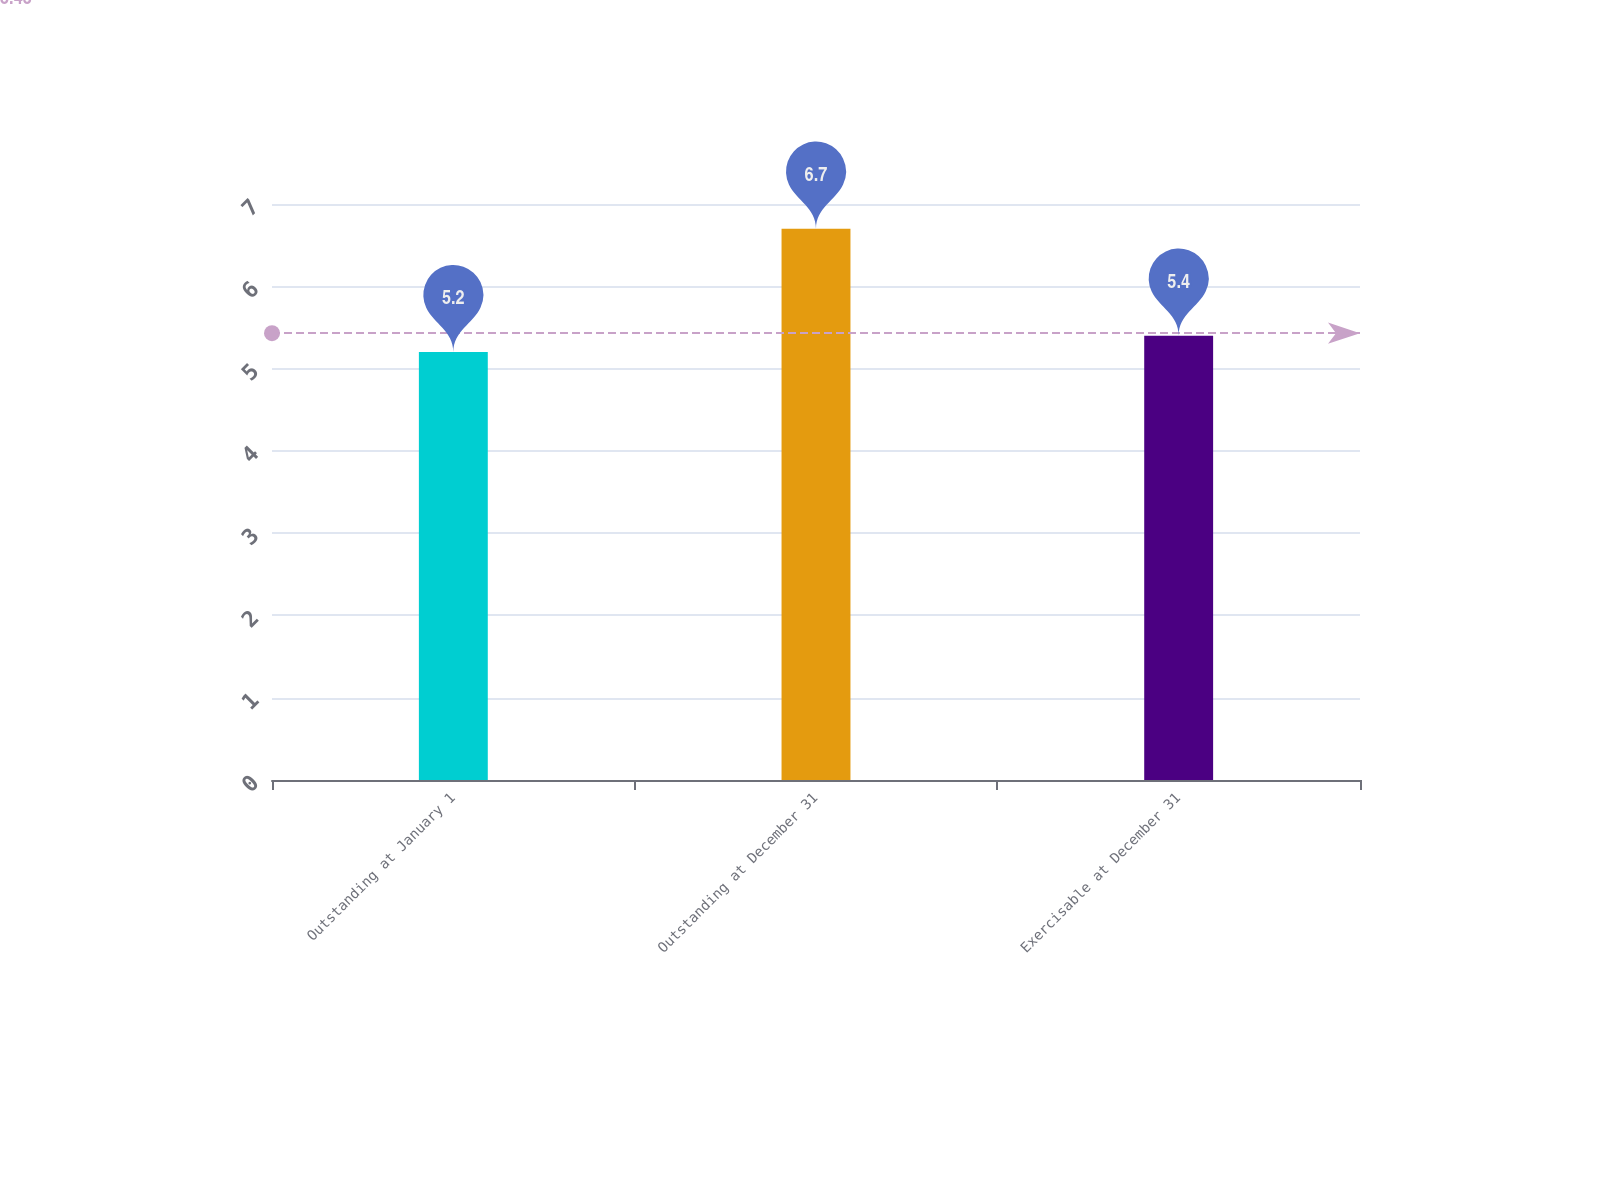Convert chart to OTSL. <chart><loc_0><loc_0><loc_500><loc_500><bar_chart><fcel>Outstanding at January 1<fcel>Outstanding at December 31<fcel>Exercisable at December 31<nl><fcel>5.2<fcel>6.7<fcel>5.4<nl></chart> 